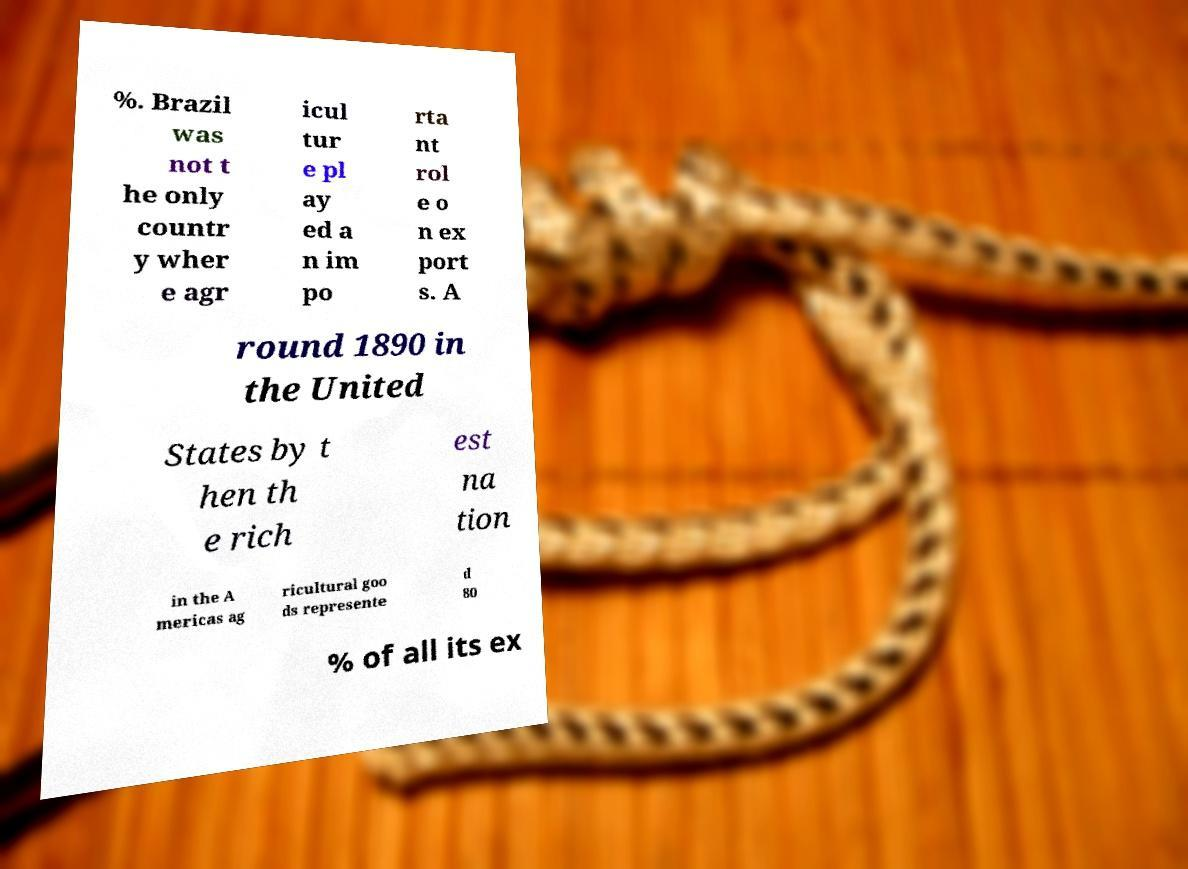There's text embedded in this image that I need extracted. Can you transcribe it verbatim? %. Brazil was not t he only countr y wher e agr icul tur e pl ay ed a n im po rta nt rol e o n ex port s. A round 1890 in the United States by t hen th e rich est na tion in the A mericas ag ricultural goo ds represente d 80 % of all its ex 